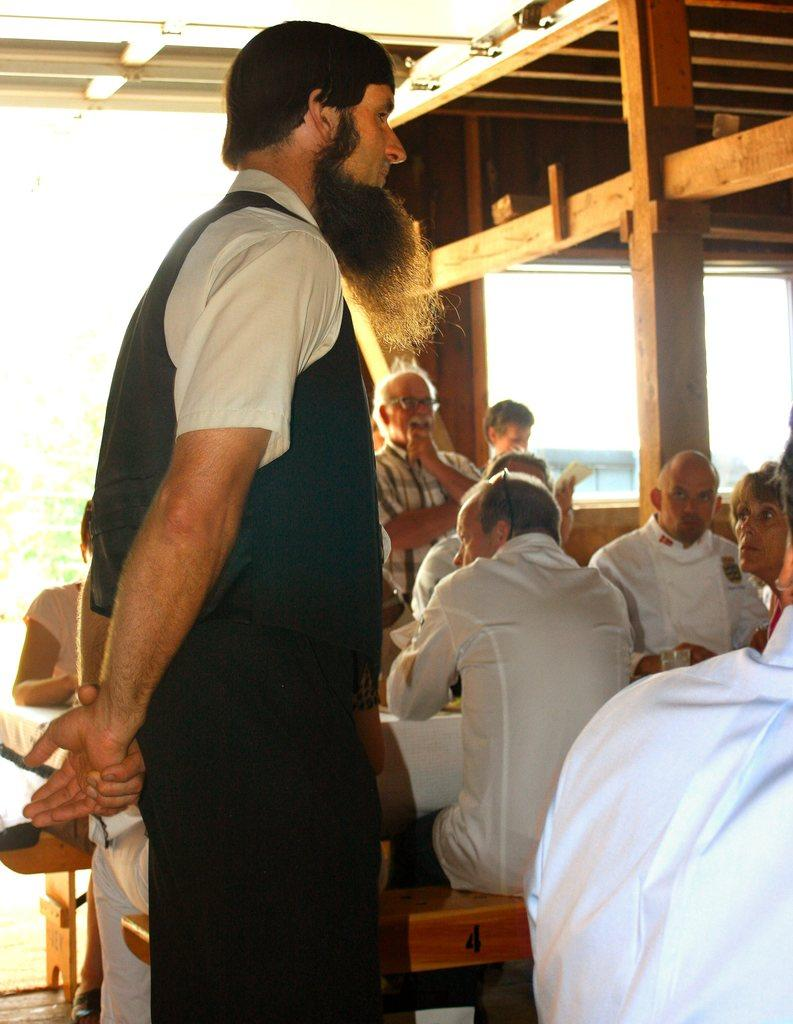What is the main subject of the image? There is a man standing in the image. Can you describe the other people in the image? There are people sitting on benches in the image. What type of baseball patch can be seen on the man's shirt in the image? There is no baseball patch or any reference to baseball in the image. 